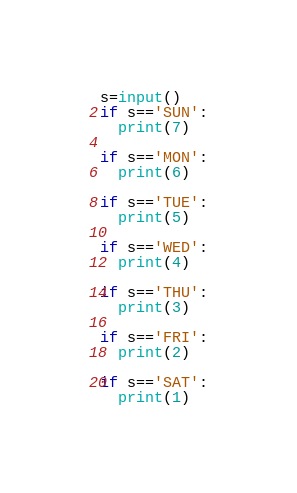<code> <loc_0><loc_0><loc_500><loc_500><_Python_>s=input()
if s=='SUN':
  print(7)

if s=='MON':
  print(6)

if s=='TUE':
  print(5)

if s=='WED':
  print(4)

if s=='THU':
  print(3)

if s=='FRI':
  print(2)

if s=='SAT':
  print(1)</code> 